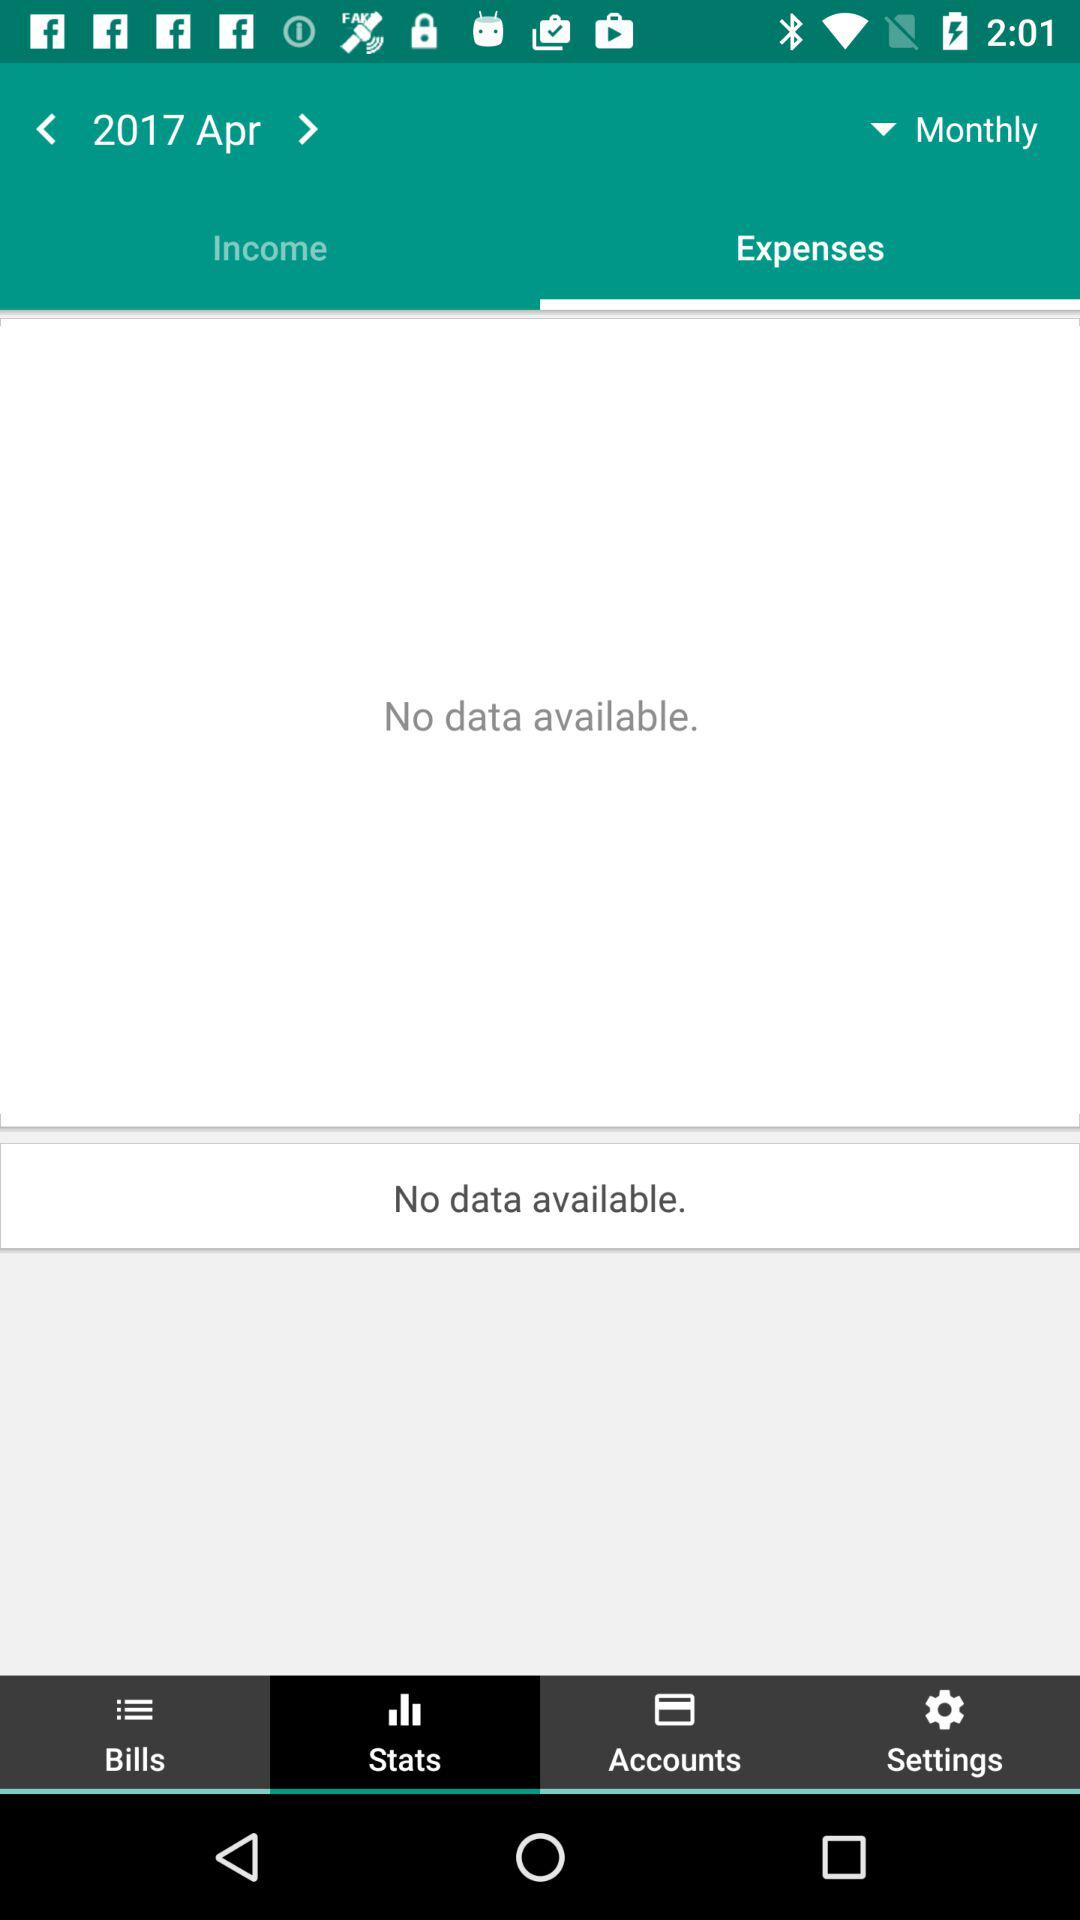Which tab is currently selected at the top? The selected tab is "Expenses". 